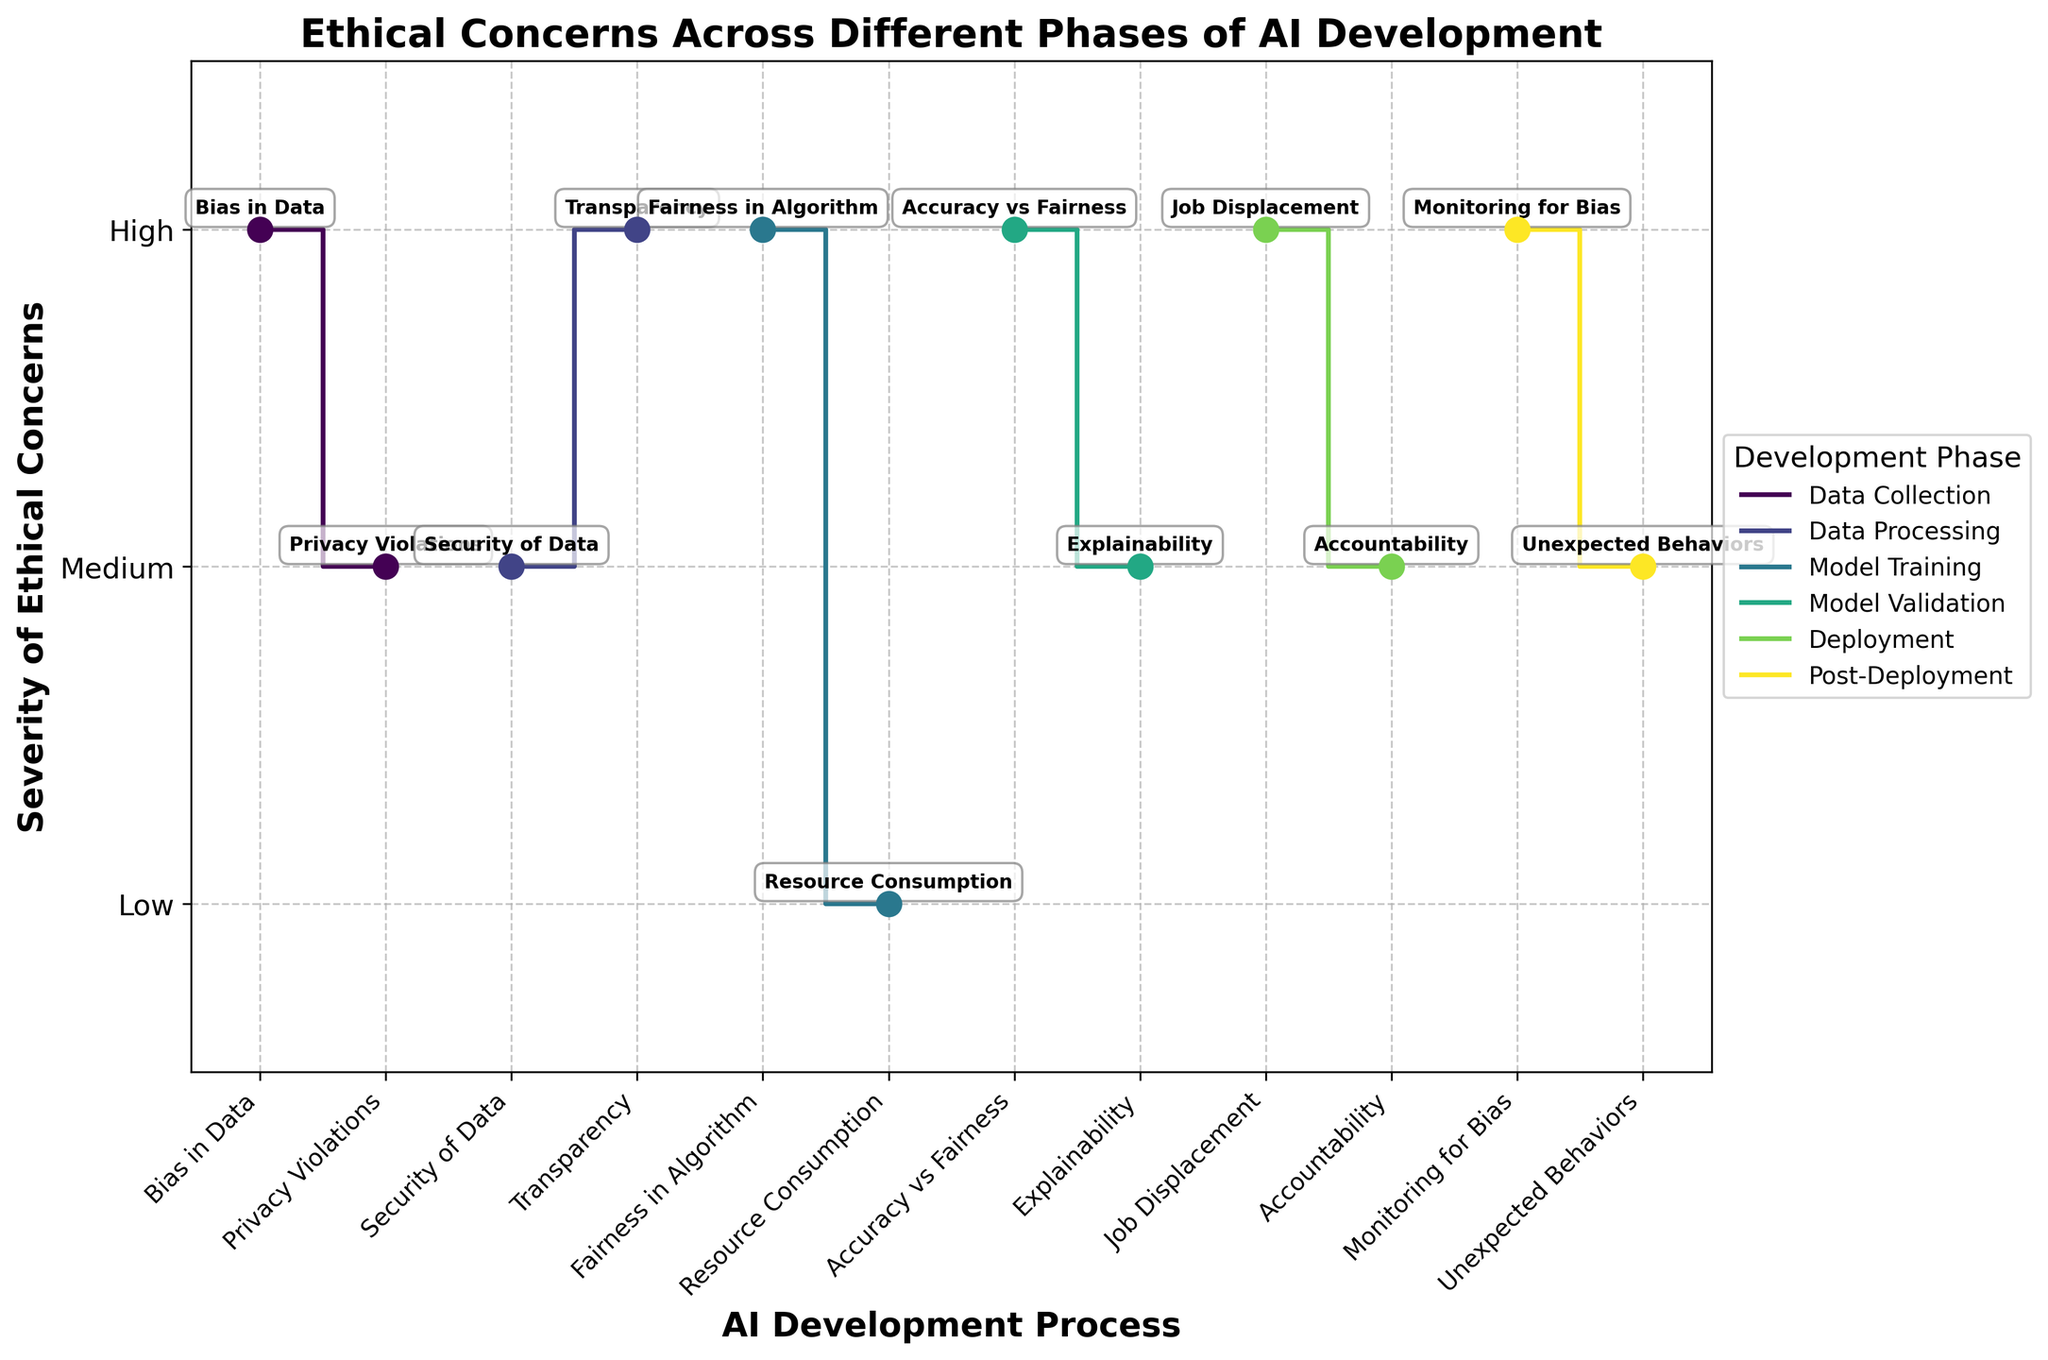What is the title of the figure? The title is generally placed at the top of the figure and it can be read directly.
Answer: Ethical Concerns Across Different Phases of AI Development What phases are compared in the figure? The phases can be identified by looking at the legend of the figure, which typically lists all the categories in the plot.
Answer: Data Collection, Data Processing, Model Training, Model Validation, Deployment, Post-Deployment Which phase has the highest number of high severity concerns? Count the number of 'High' severity points for each phase by looking at the y-values labeled as 'High'.
Answer: Data Collection, Model Training, Deployment, and Post-Deployment all have 2 high severity concerns each How many concerns have medium severity in total? Count all the data points at the 'Medium' severity level across all phases in the y-axis.
Answer: 4 What is the severity of the concern "Fairness in Algorithm"? Locate the concern "Fairness in Algorithm" on the x-axis and check its corresponding y-value labeled as 'High', 'Medium', or 'Low'.
Answer: High In which phase does the concern "Transparency" appear, and what is its severity? Trace the concern "Transparency" from the x-axis to its corresponding phase color and y-value for severity.
Answer: Data Processing, High Which phase has the concern with the severity "Privacy Violations" and what is its severity? Locate "Privacy Violations" on the x-axis and check its corresponding phase and y-value labeled as severity.
Answer: Data Collection, Medium Which phase has the least number of concerns and what is the total number of those concerns? Count the number of concerns per phase by looking at the phase colors and verifying the total number of unique concerns associated with each phase.
Answer: Deployment, 2 Between "Resource Consumption" and "Accuracy vs Fairness," which has a higher severity and what are their respective severities? Locate both concerns on the x-axis and compare their respective y-values labeled as 'High', 'Medium', or 'Low'.
Answer: "Accuracy vs Fairness" has a higher severity. "Resource Consumption" is Low, and "Accuracy vs Fairness" is High In the Post-Deployment phase, which concern has higher severity, "Monitoring for Bias" or "Unexpected Behaviors"? Compare the severity levels of both concerns in the same phase by looking at the y-values labeled as 'High', 'Medium', or 'Low'.
Answer: "Monitoring for Bias" is High, and "Unexpected Behaviors" is Medium 